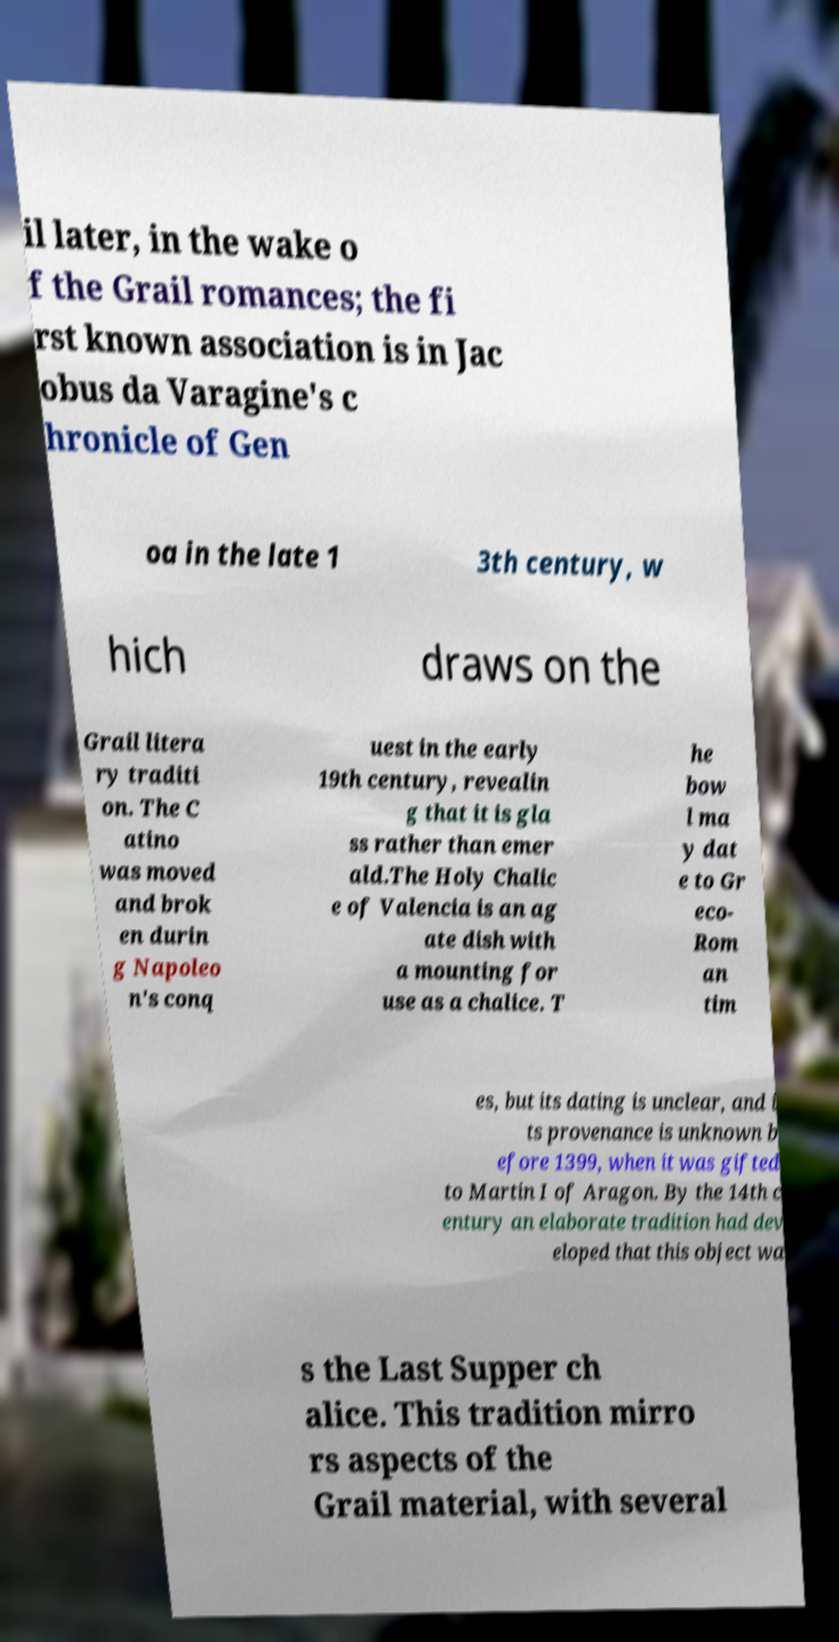What messages or text are displayed in this image? I need them in a readable, typed format. il later, in the wake o f the Grail romances; the fi rst known association is in Jac obus da Varagine's c hronicle of Gen oa in the late 1 3th century, w hich draws on the Grail litera ry traditi on. The C atino was moved and brok en durin g Napoleo n's conq uest in the early 19th century, revealin g that it is gla ss rather than emer ald.The Holy Chalic e of Valencia is an ag ate dish with a mounting for use as a chalice. T he bow l ma y dat e to Gr eco- Rom an tim es, but its dating is unclear, and i ts provenance is unknown b efore 1399, when it was gifted to Martin I of Aragon. By the 14th c entury an elaborate tradition had dev eloped that this object wa s the Last Supper ch alice. This tradition mirro rs aspects of the Grail material, with several 